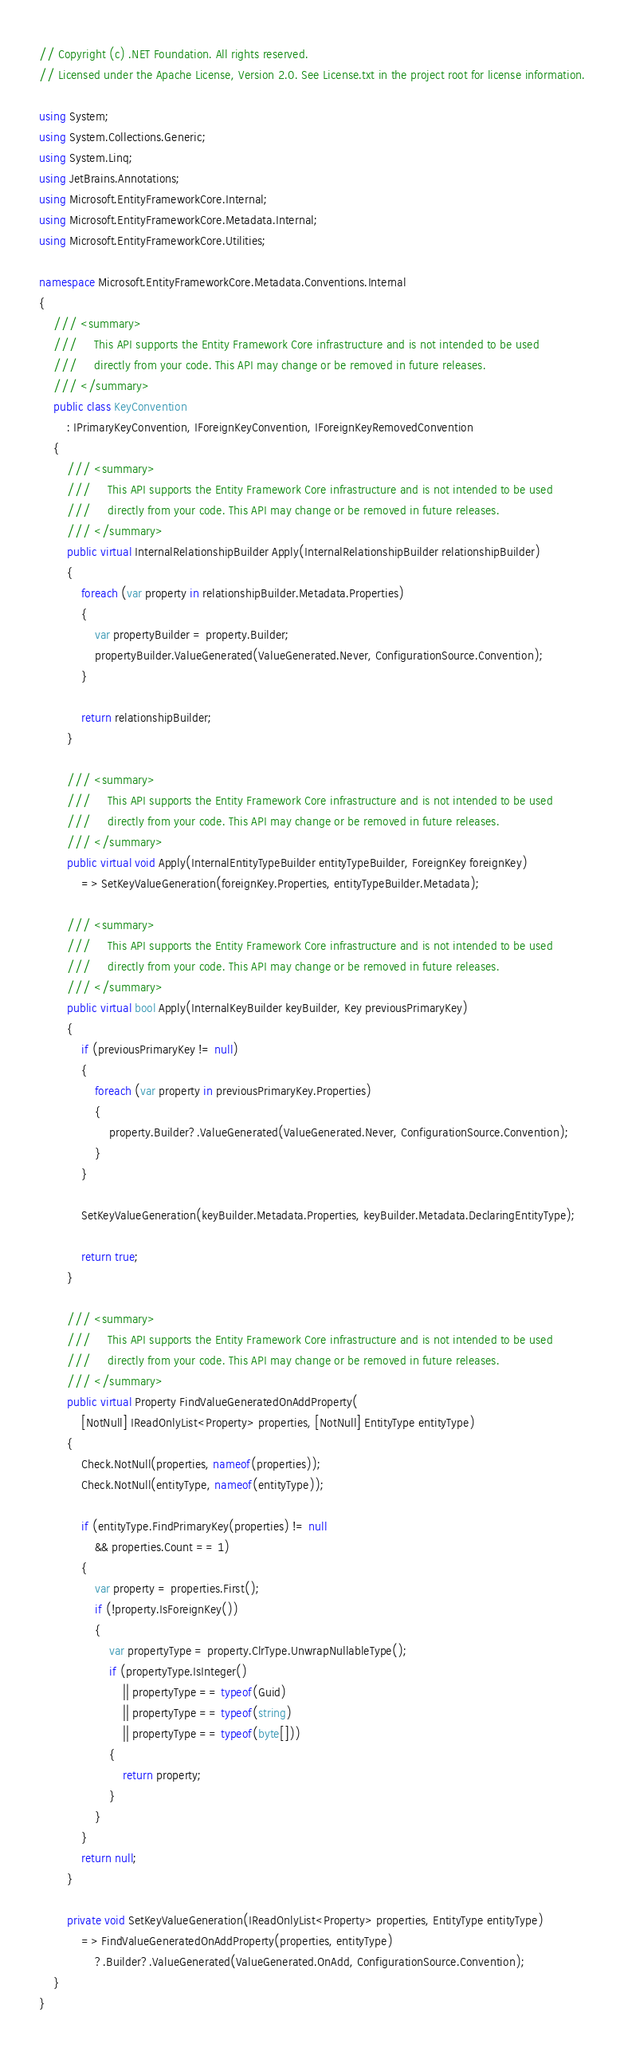<code> <loc_0><loc_0><loc_500><loc_500><_C#_>// Copyright (c) .NET Foundation. All rights reserved.
// Licensed under the Apache License, Version 2.0. See License.txt in the project root for license information.

using System;
using System.Collections.Generic;
using System.Linq;
using JetBrains.Annotations;
using Microsoft.EntityFrameworkCore.Internal;
using Microsoft.EntityFrameworkCore.Metadata.Internal;
using Microsoft.EntityFrameworkCore.Utilities;

namespace Microsoft.EntityFrameworkCore.Metadata.Conventions.Internal
{
    /// <summary>
    ///     This API supports the Entity Framework Core infrastructure and is not intended to be used 
    ///     directly from your code. This API may change or be removed in future releases.
    /// </summary>
    public class KeyConvention
        : IPrimaryKeyConvention, IForeignKeyConvention, IForeignKeyRemovedConvention
    {
        /// <summary>
        ///     This API supports the Entity Framework Core infrastructure and is not intended to be used 
        ///     directly from your code. This API may change or be removed in future releases.
        /// </summary>
        public virtual InternalRelationshipBuilder Apply(InternalRelationshipBuilder relationshipBuilder)
        {
            foreach (var property in relationshipBuilder.Metadata.Properties)
            {
                var propertyBuilder = property.Builder;
                propertyBuilder.ValueGenerated(ValueGenerated.Never, ConfigurationSource.Convention);
            }

            return relationshipBuilder;
        }

        /// <summary>
        ///     This API supports the Entity Framework Core infrastructure and is not intended to be used 
        ///     directly from your code. This API may change or be removed in future releases.
        /// </summary>
        public virtual void Apply(InternalEntityTypeBuilder entityTypeBuilder, ForeignKey foreignKey)
            => SetKeyValueGeneration(foreignKey.Properties, entityTypeBuilder.Metadata);

        /// <summary>
        ///     This API supports the Entity Framework Core infrastructure and is not intended to be used 
        ///     directly from your code. This API may change or be removed in future releases.
        /// </summary>
        public virtual bool Apply(InternalKeyBuilder keyBuilder, Key previousPrimaryKey)
        {
            if (previousPrimaryKey != null)
            {
                foreach (var property in previousPrimaryKey.Properties)
                {
                    property.Builder?.ValueGenerated(ValueGenerated.Never, ConfigurationSource.Convention);
                }
            }

            SetKeyValueGeneration(keyBuilder.Metadata.Properties, keyBuilder.Metadata.DeclaringEntityType);

            return true;
        }

        /// <summary>
        ///     This API supports the Entity Framework Core infrastructure and is not intended to be used 
        ///     directly from your code. This API may change or be removed in future releases.
        /// </summary>
        public virtual Property FindValueGeneratedOnAddProperty(
            [NotNull] IReadOnlyList<Property> properties, [NotNull] EntityType entityType)
        {
            Check.NotNull(properties, nameof(properties));
            Check.NotNull(entityType, nameof(entityType));

            if (entityType.FindPrimaryKey(properties) != null
                && properties.Count == 1)
            {
                var property = properties.First();
                if (!property.IsForeignKey())
                {
                    var propertyType = property.ClrType.UnwrapNullableType();
                    if (propertyType.IsInteger()
                        || propertyType == typeof(Guid)
                        || propertyType == typeof(string)
                        || propertyType == typeof(byte[]))
                    {
                        return property;
                    }
                }
            }
            return null;
        }

        private void SetKeyValueGeneration(IReadOnlyList<Property> properties, EntityType entityType)
            => FindValueGeneratedOnAddProperty(properties, entityType)
                ?.Builder?.ValueGenerated(ValueGenerated.OnAdd, ConfigurationSource.Convention);
    }
}
</code> 